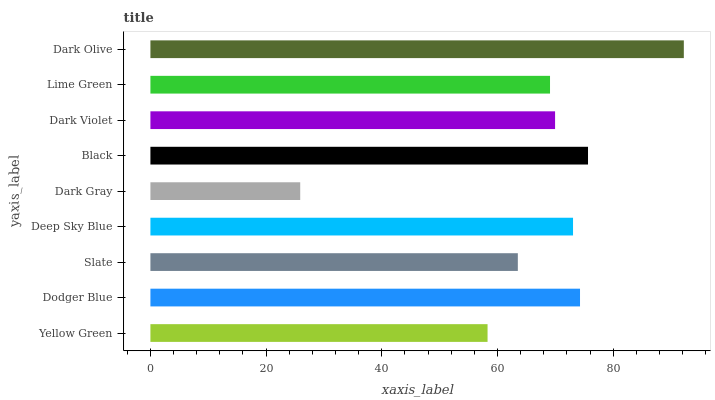Is Dark Gray the minimum?
Answer yes or no. Yes. Is Dark Olive the maximum?
Answer yes or no. Yes. Is Dodger Blue the minimum?
Answer yes or no. No. Is Dodger Blue the maximum?
Answer yes or no. No. Is Dodger Blue greater than Yellow Green?
Answer yes or no. Yes. Is Yellow Green less than Dodger Blue?
Answer yes or no. Yes. Is Yellow Green greater than Dodger Blue?
Answer yes or no. No. Is Dodger Blue less than Yellow Green?
Answer yes or no. No. Is Dark Violet the high median?
Answer yes or no. Yes. Is Dark Violet the low median?
Answer yes or no. Yes. Is Dark Olive the high median?
Answer yes or no. No. Is Deep Sky Blue the low median?
Answer yes or no. No. 